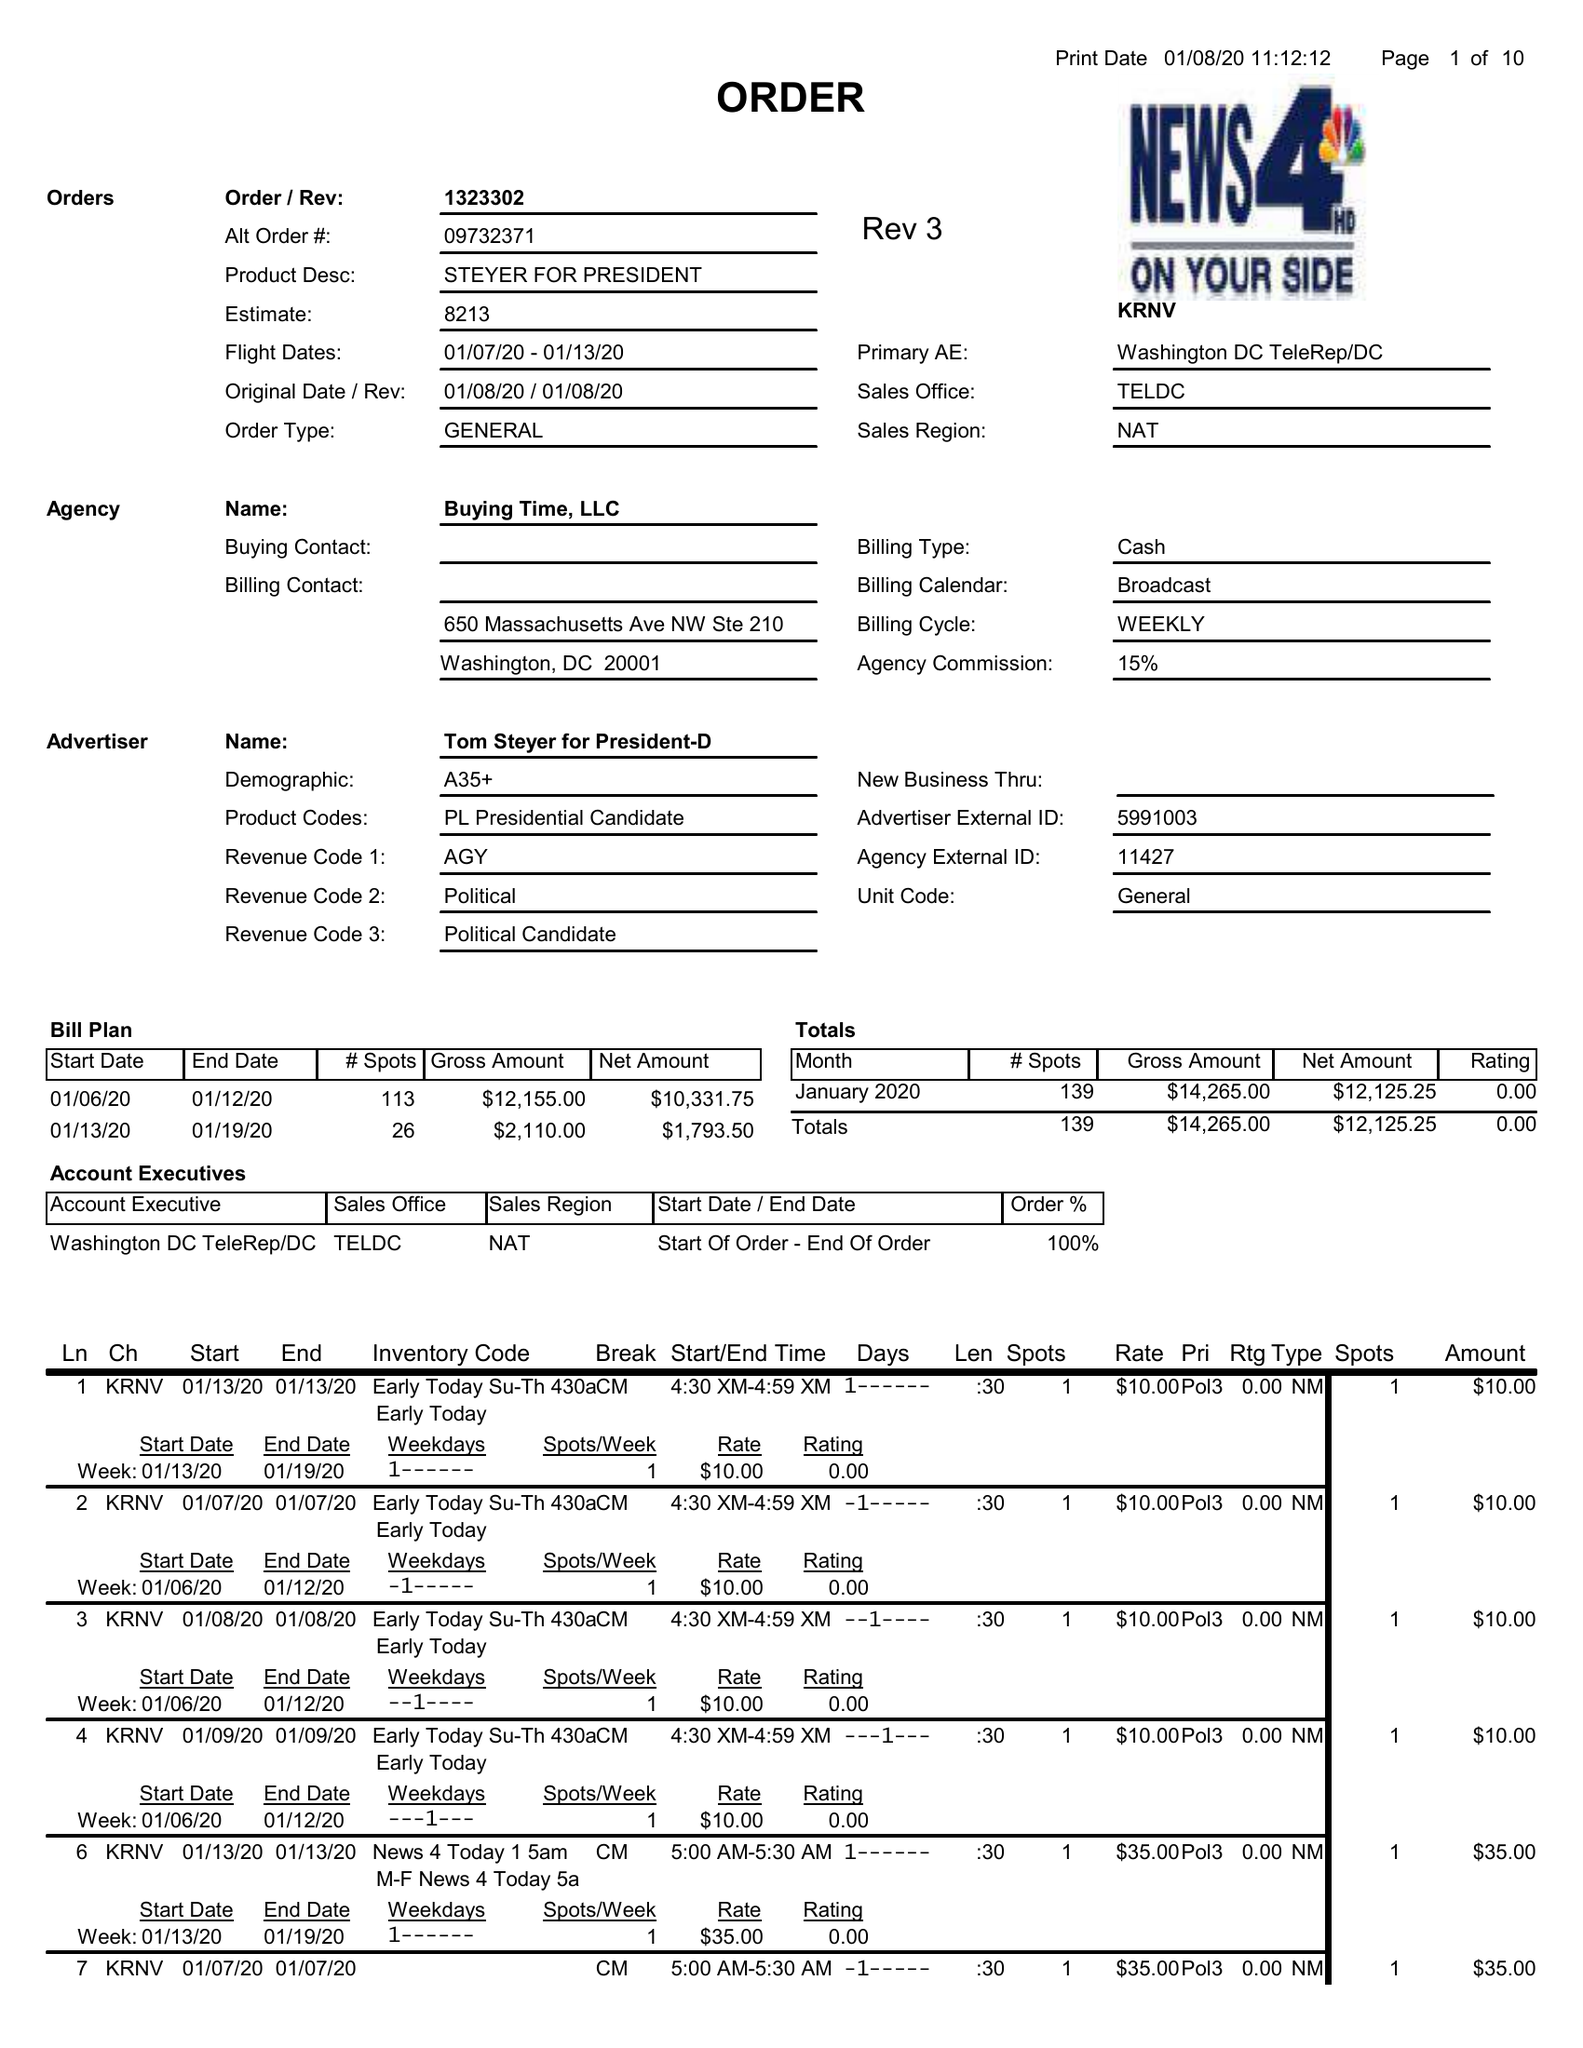What is the value for the advertiser?
Answer the question using a single word or phrase. TOM STEYER FOR PRESIDENT-D 